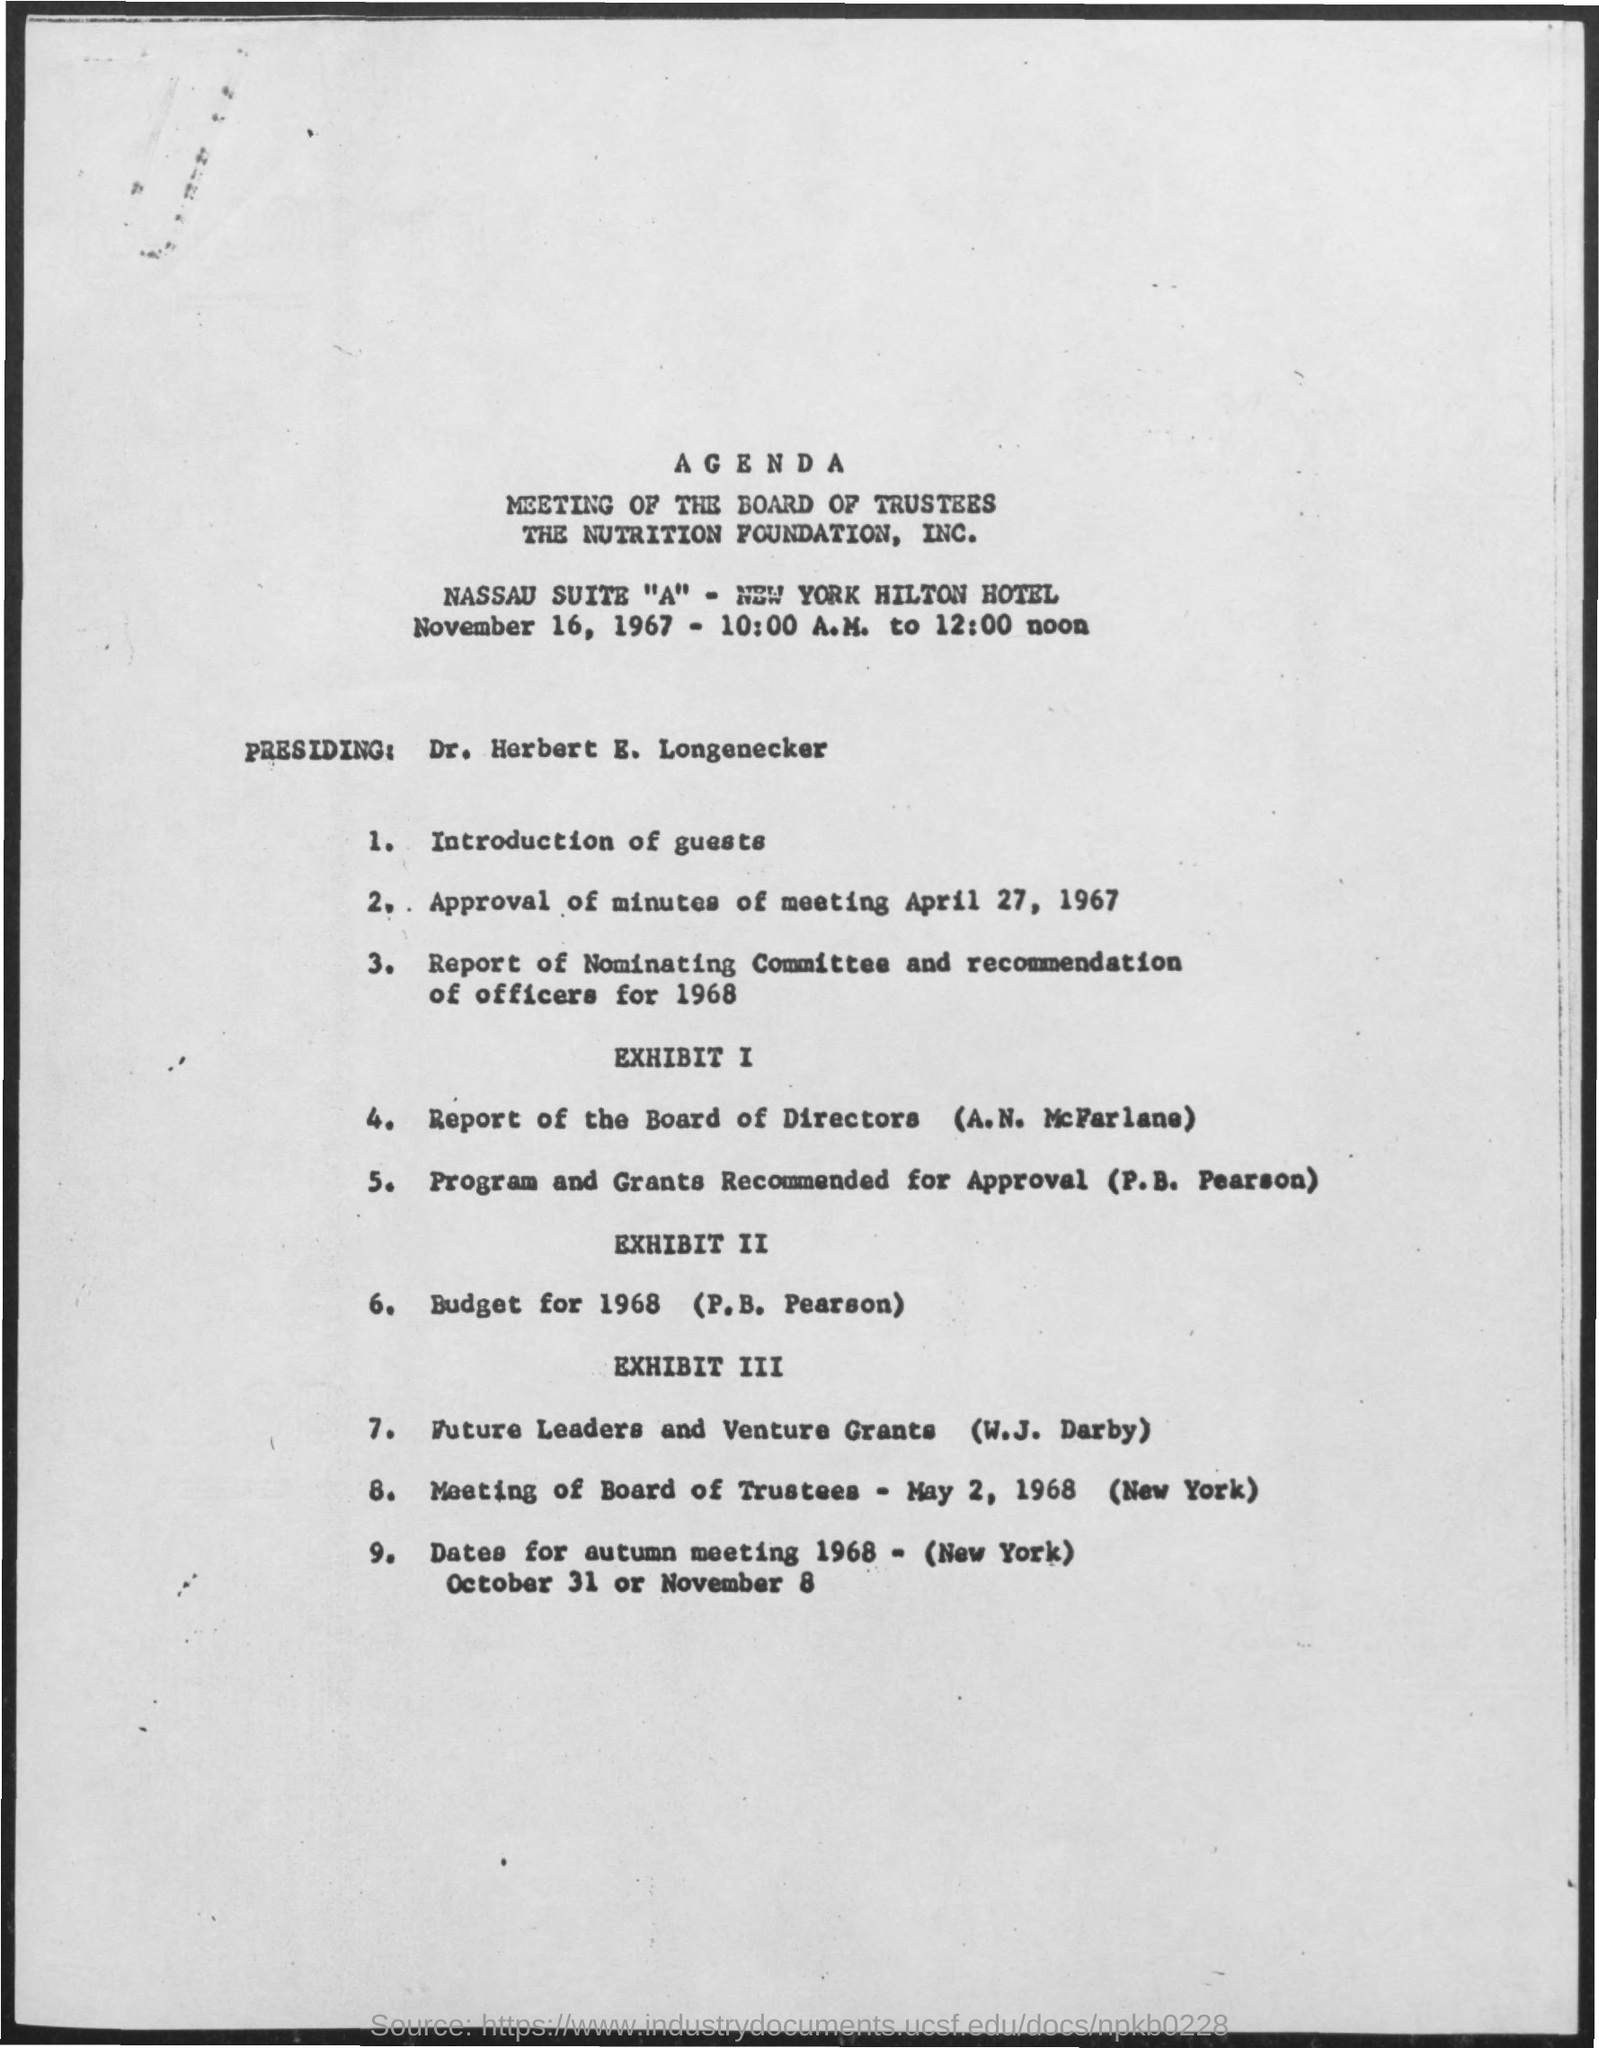What is the time mentioned in the given form ?
Offer a very short reply. 10:00 A.M. to 12:00 noon. 